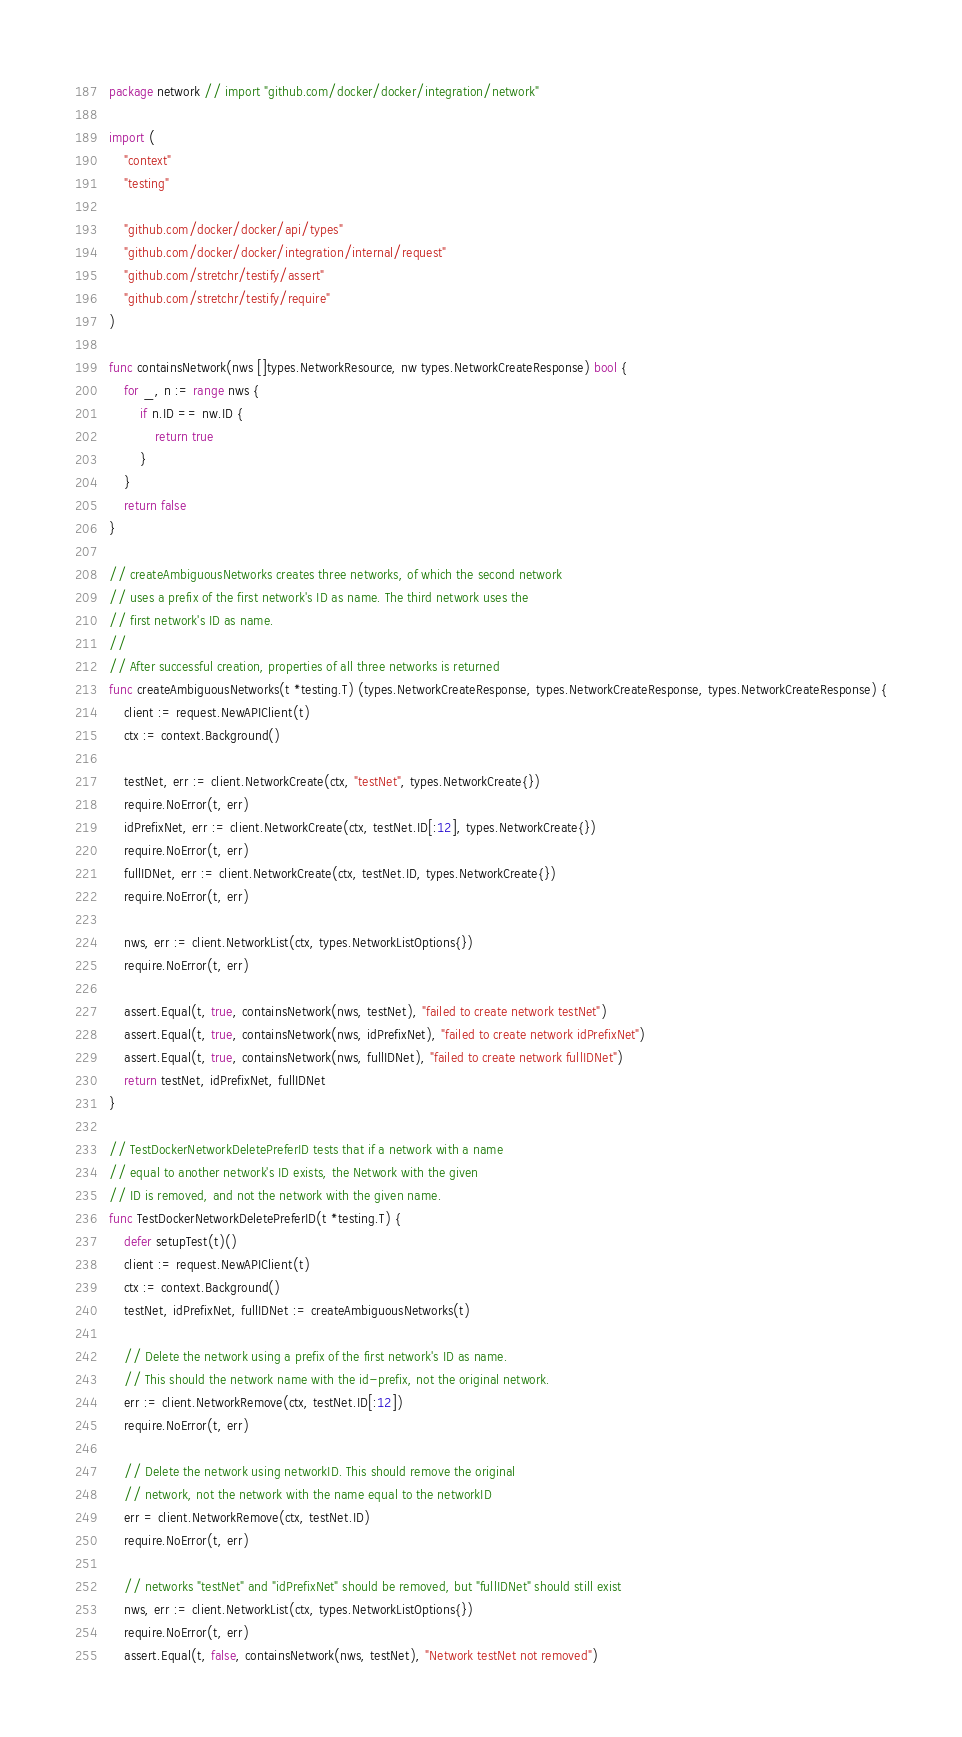<code> <loc_0><loc_0><loc_500><loc_500><_Go_>package network // import "github.com/docker/docker/integration/network"

import (
	"context"
	"testing"

	"github.com/docker/docker/api/types"
	"github.com/docker/docker/integration/internal/request"
	"github.com/stretchr/testify/assert"
	"github.com/stretchr/testify/require"
)

func containsNetwork(nws []types.NetworkResource, nw types.NetworkCreateResponse) bool {
	for _, n := range nws {
		if n.ID == nw.ID {
			return true
		}
	}
	return false
}

// createAmbiguousNetworks creates three networks, of which the second network
// uses a prefix of the first network's ID as name. The third network uses the
// first network's ID as name.
//
// After successful creation, properties of all three networks is returned
func createAmbiguousNetworks(t *testing.T) (types.NetworkCreateResponse, types.NetworkCreateResponse, types.NetworkCreateResponse) {
	client := request.NewAPIClient(t)
	ctx := context.Background()

	testNet, err := client.NetworkCreate(ctx, "testNet", types.NetworkCreate{})
	require.NoError(t, err)
	idPrefixNet, err := client.NetworkCreate(ctx, testNet.ID[:12], types.NetworkCreate{})
	require.NoError(t, err)
	fullIDNet, err := client.NetworkCreate(ctx, testNet.ID, types.NetworkCreate{})
	require.NoError(t, err)

	nws, err := client.NetworkList(ctx, types.NetworkListOptions{})
	require.NoError(t, err)

	assert.Equal(t, true, containsNetwork(nws, testNet), "failed to create network testNet")
	assert.Equal(t, true, containsNetwork(nws, idPrefixNet), "failed to create network idPrefixNet")
	assert.Equal(t, true, containsNetwork(nws, fullIDNet), "failed to create network fullIDNet")
	return testNet, idPrefixNet, fullIDNet
}

// TestDockerNetworkDeletePreferID tests that if a network with a name
// equal to another network's ID exists, the Network with the given
// ID is removed, and not the network with the given name.
func TestDockerNetworkDeletePreferID(t *testing.T) {
	defer setupTest(t)()
	client := request.NewAPIClient(t)
	ctx := context.Background()
	testNet, idPrefixNet, fullIDNet := createAmbiguousNetworks(t)

	// Delete the network using a prefix of the first network's ID as name.
	// This should the network name with the id-prefix, not the original network.
	err := client.NetworkRemove(ctx, testNet.ID[:12])
	require.NoError(t, err)

	// Delete the network using networkID. This should remove the original
	// network, not the network with the name equal to the networkID
	err = client.NetworkRemove(ctx, testNet.ID)
	require.NoError(t, err)

	// networks "testNet" and "idPrefixNet" should be removed, but "fullIDNet" should still exist
	nws, err := client.NetworkList(ctx, types.NetworkListOptions{})
	require.NoError(t, err)
	assert.Equal(t, false, containsNetwork(nws, testNet), "Network testNet not removed")</code> 